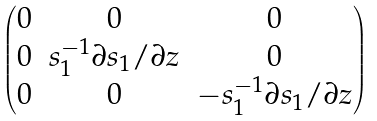<formula> <loc_0><loc_0><loc_500><loc_500>\begin{pmatrix} 0 & 0 & 0 \\ 0 & s _ { 1 } ^ { - 1 } \partial s _ { 1 } / \partial z & 0 \\ 0 & 0 & - s _ { 1 } ^ { - 1 } \partial s _ { 1 } / \partial z \end{pmatrix}</formula> 